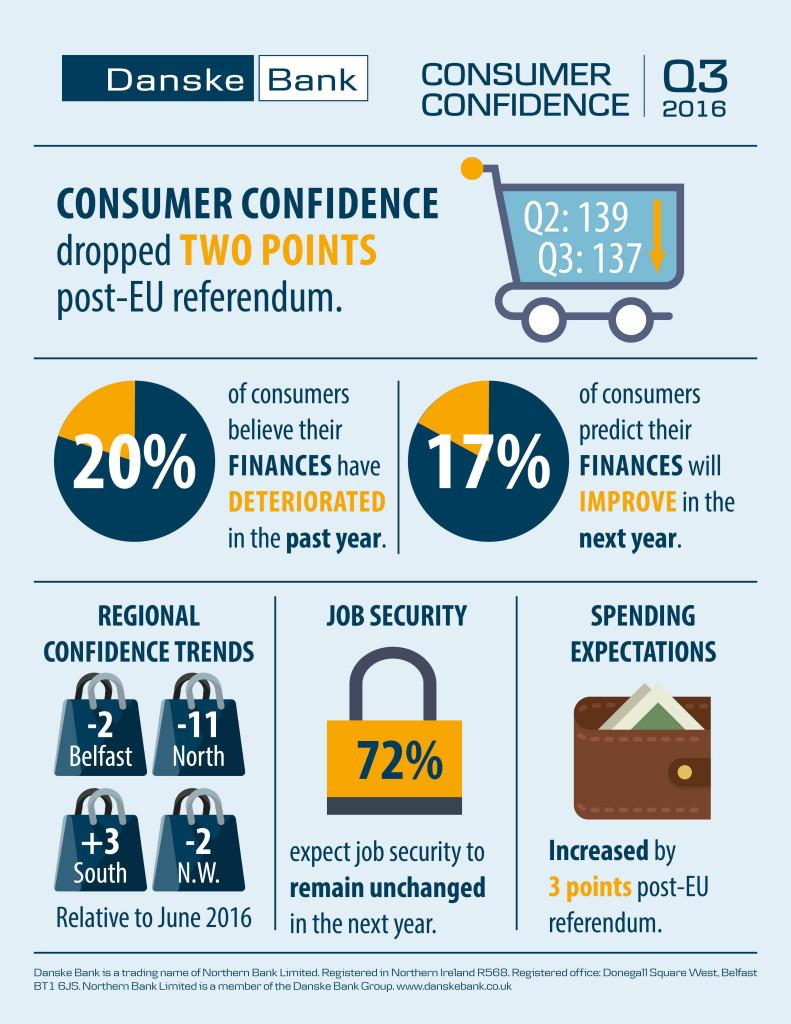Outline some significant characteristics in this image. In certain regions, the confidence level has been trending downward by approximately -2, including Belfast and North Wales. The consumer confidence considered Q2 and Q3 quarters. The confidence trend in the South region has been positive. The post-EU referendum has had a significant impact on consumer confidence, causing it to drop two points. 